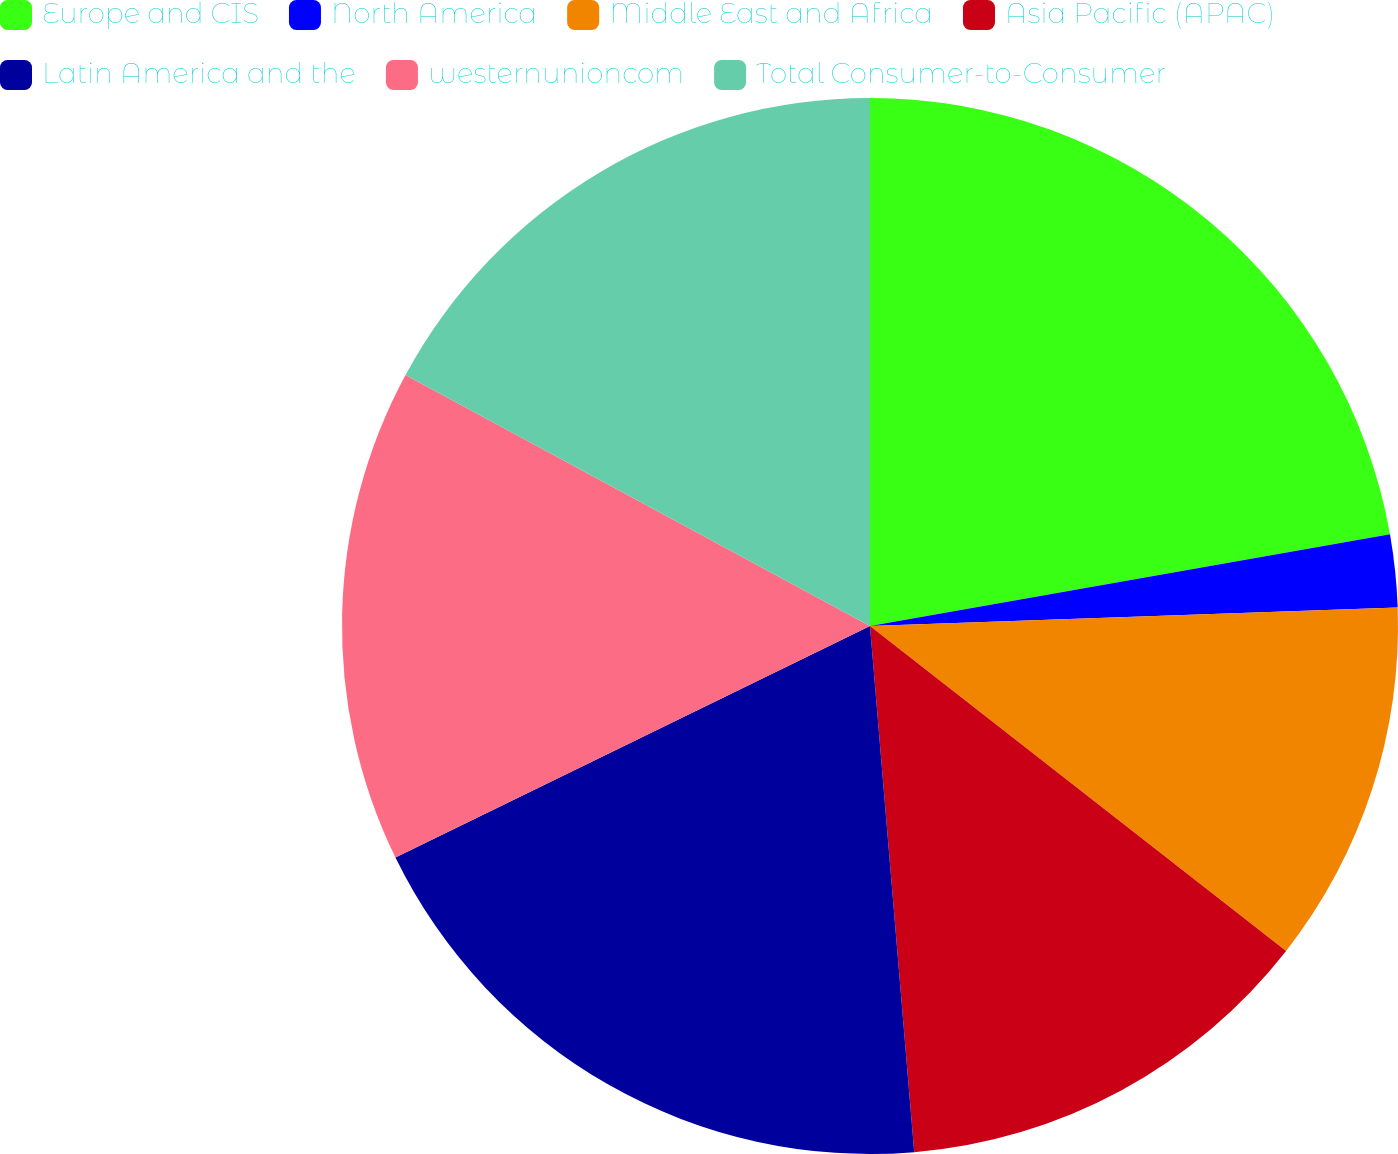Convert chart to OTSL. <chart><loc_0><loc_0><loc_500><loc_500><pie_chart><fcel>Europe and CIS<fcel>North America<fcel>Middle East and Africa<fcel>Asia Pacific (APAC)<fcel>Latin America and the<fcel>westernunioncom<fcel>Total Consumer-to-Consumer<nl><fcel>22.22%<fcel>2.22%<fcel>11.11%<fcel>13.11%<fcel>19.11%<fcel>15.11%<fcel>17.11%<nl></chart> 